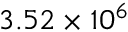Convert formula to latex. <formula><loc_0><loc_0><loc_500><loc_500>3 . 5 2 \times 1 0 ^ { 6 }</formula> 